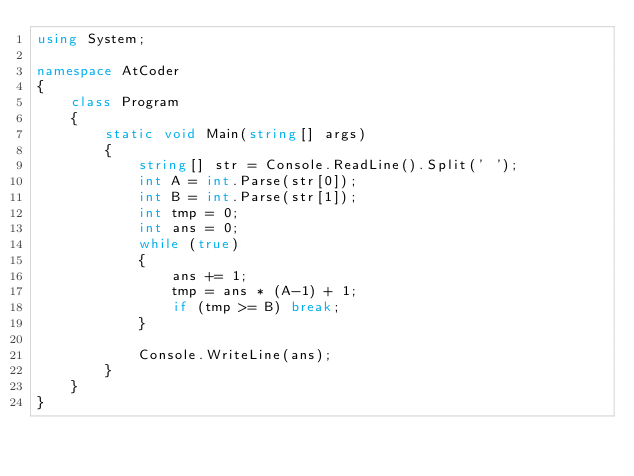Convert code to text. <code><loc_0><loc_0><loc_500><loc_500><_C#_>using System;

namespace AtCoder
{
    class Program
    {
        static void Main(string[] args)
        {
            string[] str = Console.ReadLine().Split(' ');
            int A = int.Parse(str[0]);
            int B = int.Parse(str[1]);
            int tmp = 0;
            int ans = 0;
            while (true)
            {
                ans += 1;
                tmp = ans * (A-1) + 1;
                if (tmp >= B) break;
            }

            Console.WriteLine(ans);
        }
    }
}</code> 